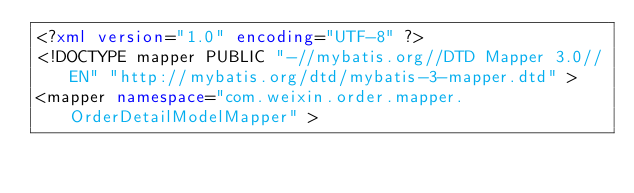Convert code to text. <code><loc_0><loc_0><loc_500><loc_500><_XML_><?xml version="1.0" encoding="UTF-8" ?>
<!DOCTYPE mapper PUBLIC "-//mybatis.org//DTD Mapper 3.0//EN" "http://mybatis.org/dtd/mybatis-3-mapper.dtd" >
<mapper namespace="com.weixin.order.mapper.OrderDetailModelMapper" ></code> 